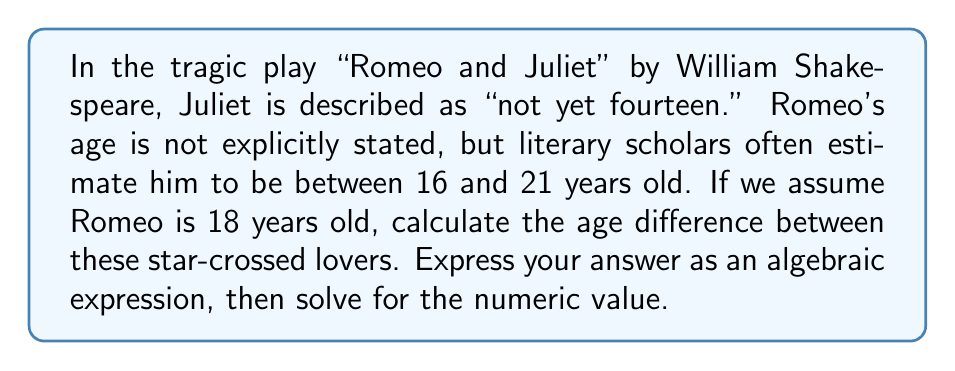Help me with this question. To solve this problem, we need to follow these steps:

1. Define variables:
   Let $j$ = Juliet's age
   Let $r$ = Romeo's age

2. Given information:
   $j = 13$ (since Juliet is "not yet fourteen")
   $r = 18$ (our assumption based on scholarly estimates)

3. Create an algebraic expression for the age difference:
   Age difference = $r - j$

4. Substitute the known values:
   Age difference = $18 - 13$

5. Solve the expression:
   $$\begin{align}
   \text{Age difference} &= 18 - 13 \\
   &= 5
   \end{align}$$

Therefore, the age difference between Romeo and Juliet is 5 years.
Answer: Algebraic expression: $r - j$
Numeric value: 5 years 